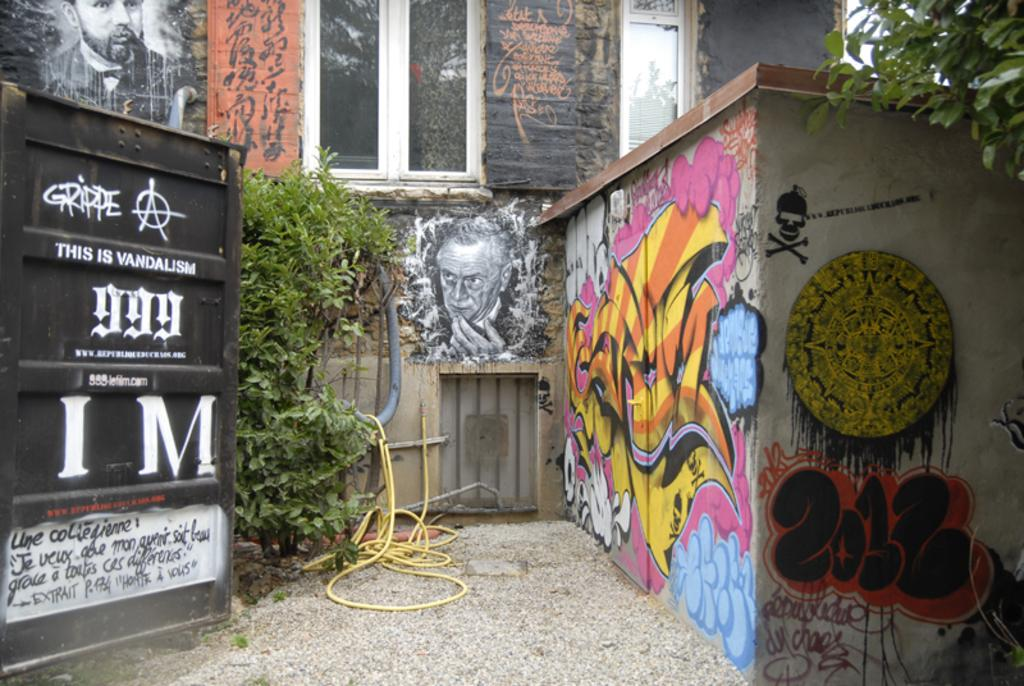What type of structure can be seen in the image? There are walls in the image. What is depicted on the walls? Pictures are painted on the walls. What type of entrance is present in the image? There is a gate in the image. What type of vegetation is present in the image? There is a plant in the image. What type of infrastructure is visible in the image? There is a pipeline in the image. What part of the ground is visible in the image? The ground is visible in the image. How much wealth is visible in the image? There is no indication of wealth in the image; it features walls, pictures, a gate, a plant, a pipeline, and the ground. Can you tell me how many people are sleeping in the image? There are no people present in the image, let alone sleeping. 